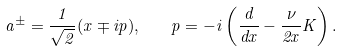<formula> <loc_0><loc_0><loc_500><loc_500>a ^ { \pm } = \frac { 1 } { \sqrt { 2 } } ( x \mp i p ) , \quad p = - i \left ( \frac { d } { d x } - \frac { \nu } { 2 x } K \right ) .</formula> 